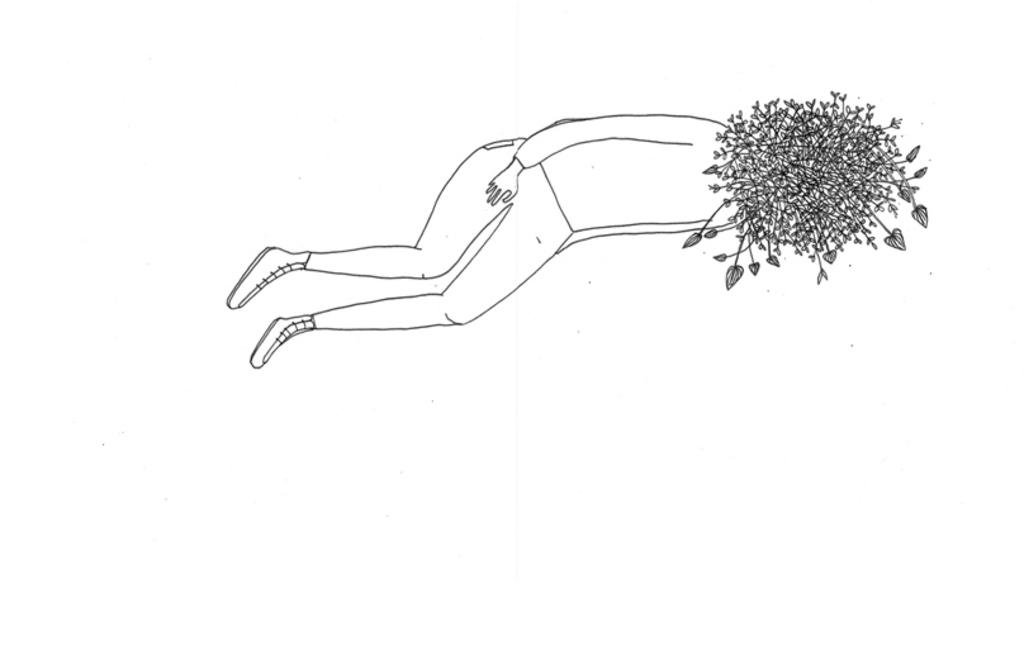What is the main subject of the image? The main subject of the image is a sketch of a person. What is the position of the person in the sketch? The person is lying on the floor in the sketch. What color is the background of the image? The background of the image is white in color. What type of truck can be seen in the image? There is no truck present in the image; it is a sketch of a person lying on the floor with a white background. 